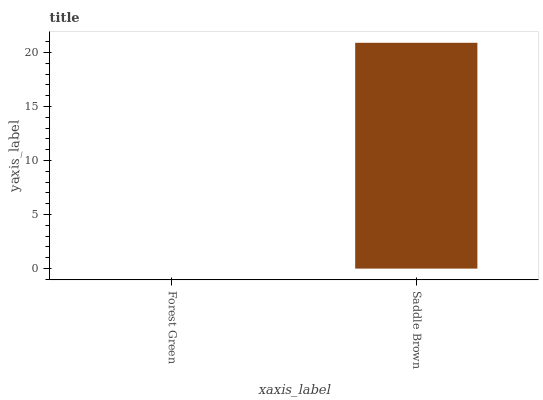Is Saddle Brown the minimum?
Answer yes or no. No. Is Saddle Brown greater than Forest Green?
Answer yes or no. Yes. Is Forest Green less than Saddle Brown?
Answer yes or no. Yes. Is Forest Green greater than Saddle Brown?
Answer yes or no. No. Is Saddle Brown less than Forest Green?
Answer yes or no. No. Is Saddle Brown the high median?
Answer yes or no. Yes. Is Forest Green the low median?
Answer yes or no. Yes. Is Forest Green the high median?
Answer yes or no. No. Is Saddle Brown the low median?
Answer yes or no. No. 